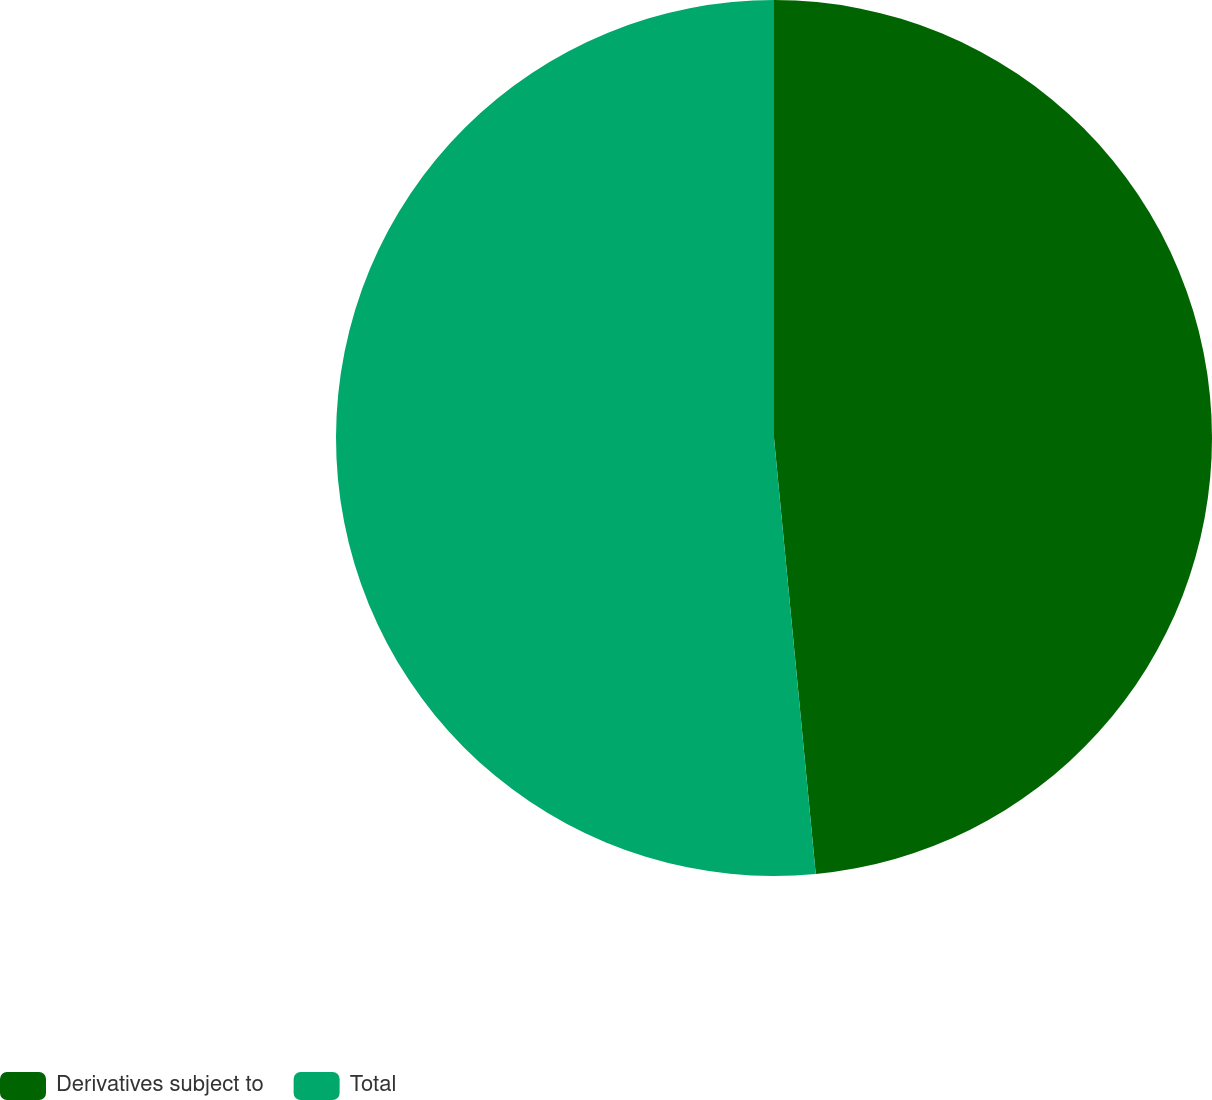<chart> <loc_0><loc_0><loc_500><loc_500><pie_chart><fcel>Derivatives subject to<fcel>Total<nl><fcel>48.48%<fcel>51.52%<nl></chart> 